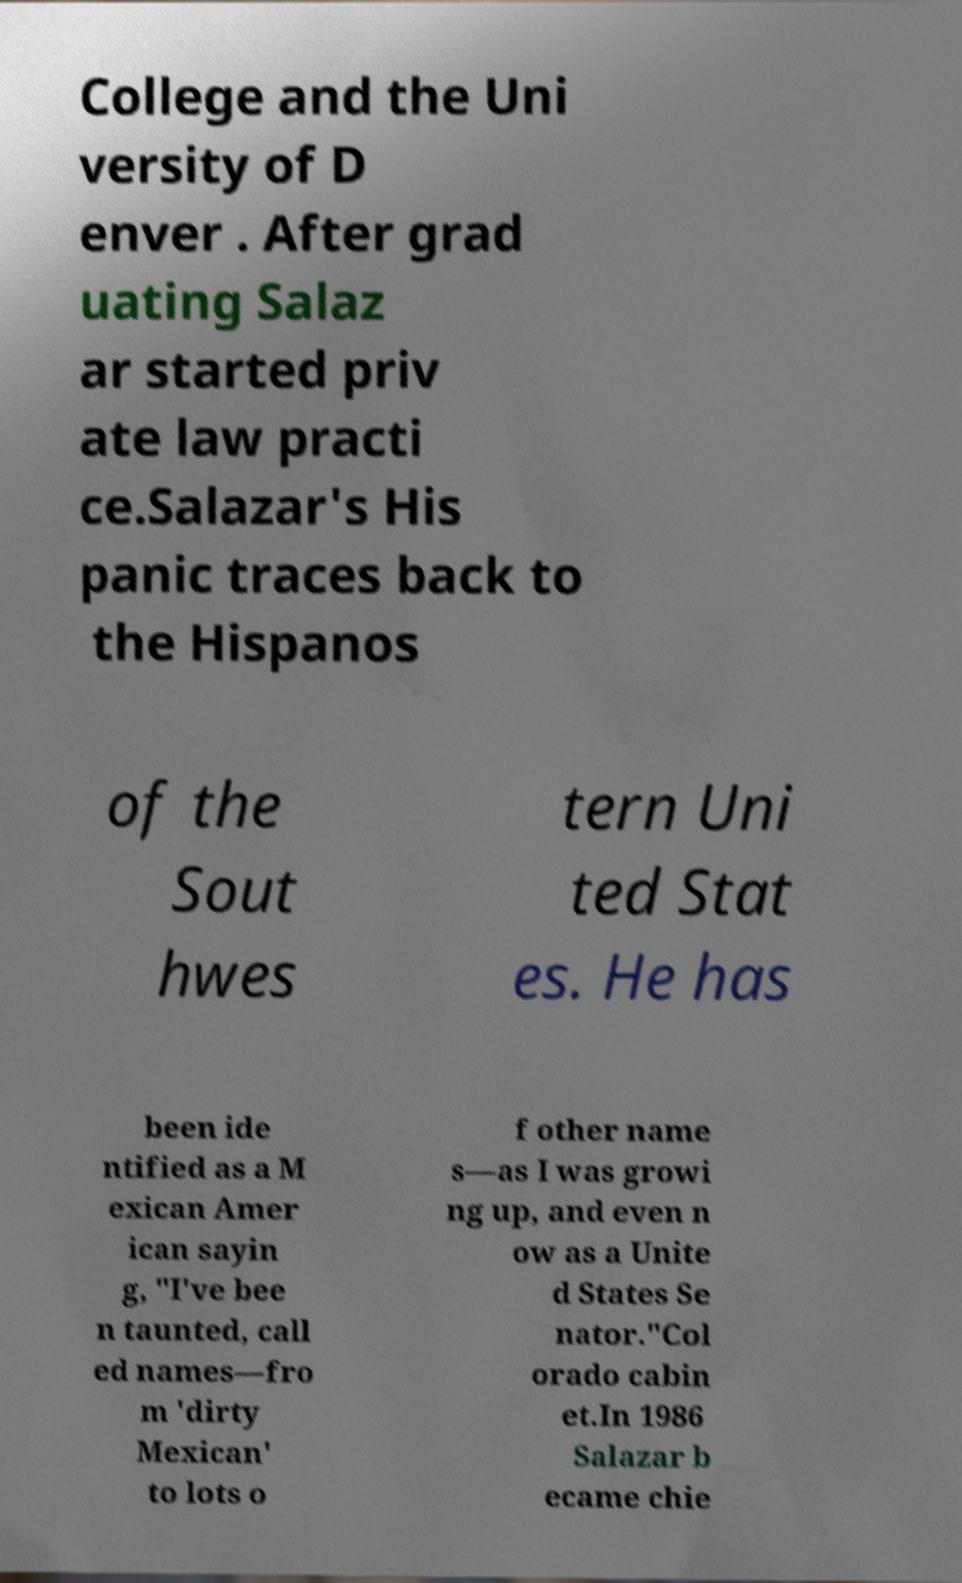There's text embedded in this image that I need extracted. Can you transcribe it verbatim? College and the Uni versity of D enver . After grad uating Salaz ar started priv ate law practi ce.Salazar's His panic traces back to the Hispanos of the Sout hwes tern Uni ted Stat es. He has been ide ntified as a M exican Amer ican sayin g, "I've bee n taunted, call ed names—fro m 'dirty Mexican' to lots o f other name s—as I was growi ng up, and even n ow as a Unite d States Se nator."Col orado cabin et.In 1986 Salazar b ecame chie 